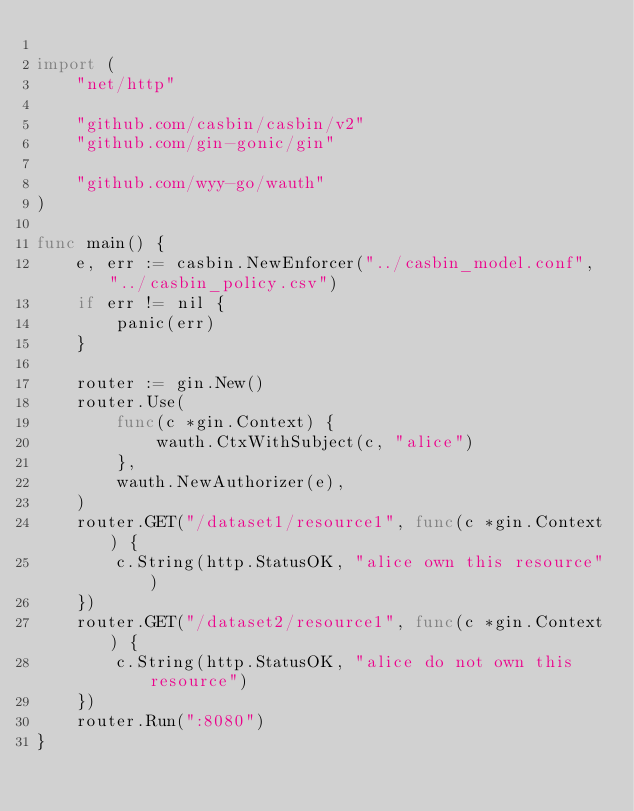<code> <loc_0><loc_0><loc_500><loc_500><_Go_>
import (
	"net/http"

	"github.com/casbin/casbin/v2"
	"github.com/gin-gonic/gin"

	"github.com/wyy-go/wauth"
)

func main() {
	e, err := casbin.NewEnforcer("../casbin_model.conf", "../casbin_policy.csv")
	if err != nil {
		panic(err)
	}

	router := gin.New()
	router.Use(
		func(c *gin.Context) {
			wauth.CtxWithSubject(c, "alice")
		},
		wauth.NewAuthorizer(e),
	)
	router.GET("/dataset1/resource1", func(c *gin.Context) {
		c.String(http.StatusOK, "alice own this resource")
	})
	router.GET("/dataset2/resource1", func(c *gin.Context) {
		c.String(http.StatusOK, "alice do not own this resource")
	})
	router.Run(":8080")
}
</code> 